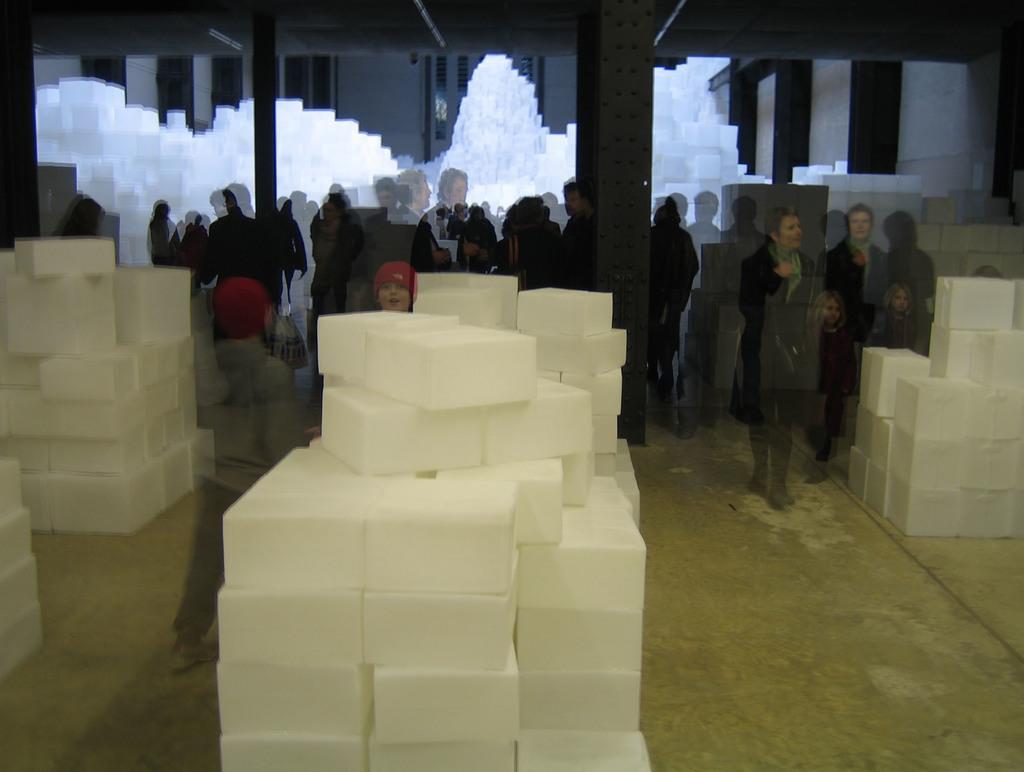Can you describe this image briefly? This is an animated image. On the left side, there are white color boxes arranged on the floor. In the middle of the image, there are white color boxes arranged on the floor. On the right side, there are white color boxes arranged on the floor. Beside these boxes, there are persons. In the background, there are pillars. And the background is blurred. 